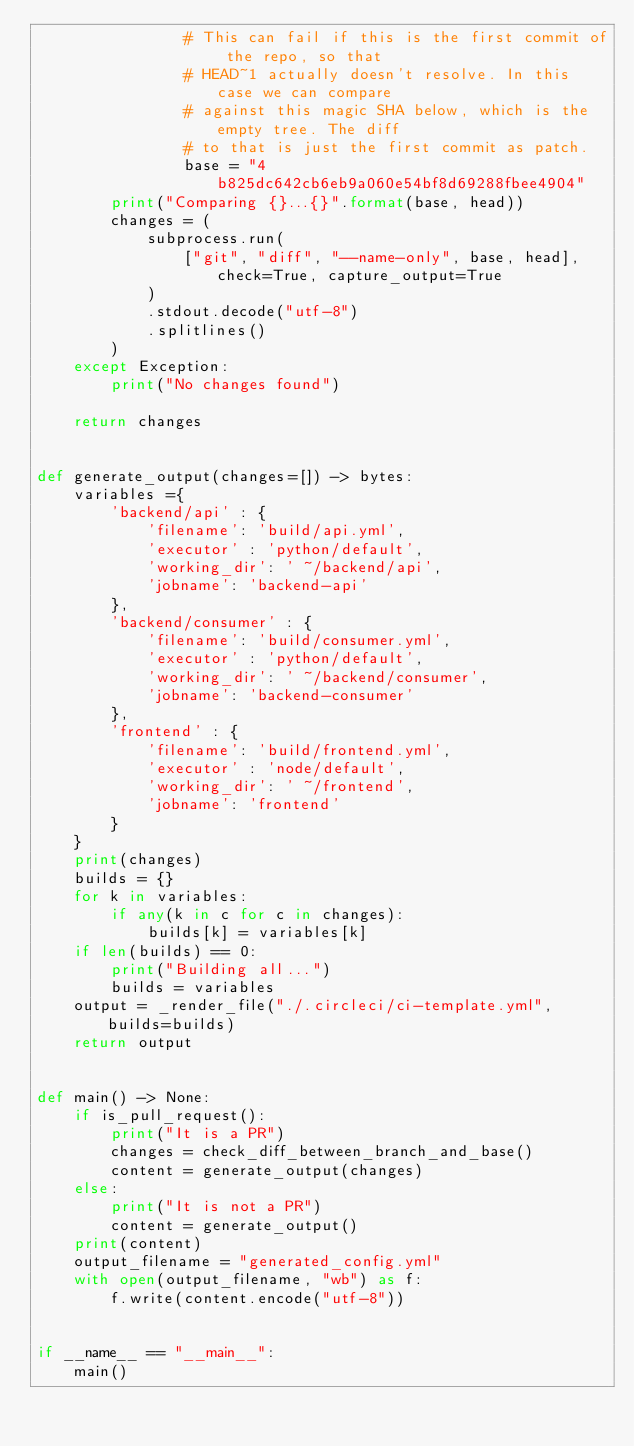<code> <loc_0><loc_0><loc_500><loc_500><_Python_>                # This can fail if this is the first commit of the repo, so that
                # HEAD~1 actually doesn't resolve. In this case we can compare
                # against this magic SHA below, which is the empty tree. The diff
                # to that is just the first commit as patch.
                base = "4b825dc642cb6eb9a060e54bf8d69288fbee4904"
        print("Comparing {}...{}".format(base, head))
        changes = (
            subprocess.run(
                ["git", "diff", "--name-only", base, head], check=True, capture_output=True
            )
            .stdout.decode("utf-8")
            .splitlines()
        )
    except Exception:
        print("No changes found")

    return changes


def generate_output(changes=[]) -> bytes:
    variables ={
        'backend/api' : {
            'filename': 'build/api.yml',
            'executor' : 'python/default',
            'working_dir': ' ~/backend/api',
            'jobname': 'backend-api'
        },
        'backend/consumer' : {
            'filename': 'build/consumer.yml',
            'executor' : 'python/default',
            'working_dir': ' ~/backend/consumer',
            'jobname': 'backend-consumer'
        },
        'frontend' : {
            'filename': 'build/frontend.yml',
            'executor' : 'node/default',
            'working_dir': ' ~/frontend',
            'jobname': 'frontend'
        }
    }
    print(changes)
    builds = {}
    for k in variables:
        if any(k in c for c in changes):
            builds[k] = variables[k]
    if len(builds) == 0:
        print("Building all...")
        builds = variables
    output = _render_file("./.circleci/ci-template.yml", builds=builds)
    return output


def main() -> None:
    if is_pull_request():
        print("It is a PR")
        changes = check_diff_between_branch_and_base()
        content = generate_output(changes)
    else:
        print("It is not a PR")
        content = generate_output()
    print(content)
    output_filename = "generated_config.yml"
    with open(output_filename, "wb") as f:
        f.write(content.encode("utf-8"))


if __name__ == "__main__":
    main()
</code> 